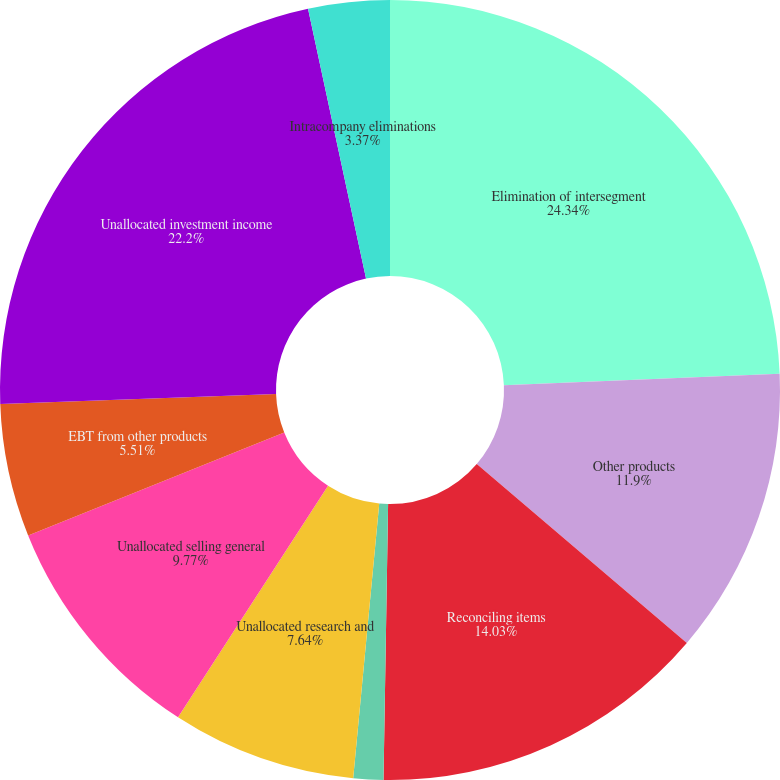Convert chart. <chart><loc_0><loc_0><loc_500><loc_500><pie_chart><fcel>Elimination of intersegment<fcel>Other products<fcel>Reconciling items<fcel>Unallocated amortization of<fcel>Unallocated research and<fcel>Unallocated selling general<fcel>EBT from other products<fcel>Unallocated investment income<fcel>Intracompany eliminations<nl><fcel>24.33%<fcel>11.9%<fcel>14.03%<fcel>1.24%<fcel>7.64%<fcel>9.77%<fcel>5.51%<fcel>22.2%<fcel>3.37%<nl></chart> 